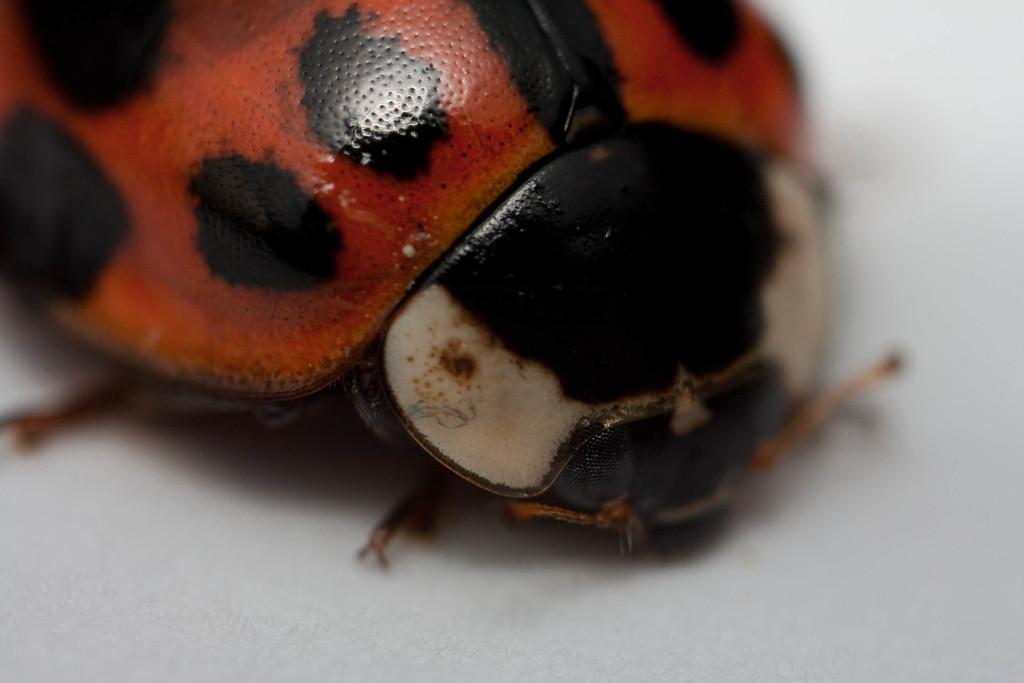What type of creature is in the image? There is an insect in the image. What colors can be seen on the insect? The insect has orange, black, and cream colors. What is the background or surface on which the insect is located? The insect is on a white colored surface. Is the insect wearing a stocking while swinging on the white surface in the image? There is no indication in the image that the insect is wearing a stocking or swinging; it is simply located on the white surface. 